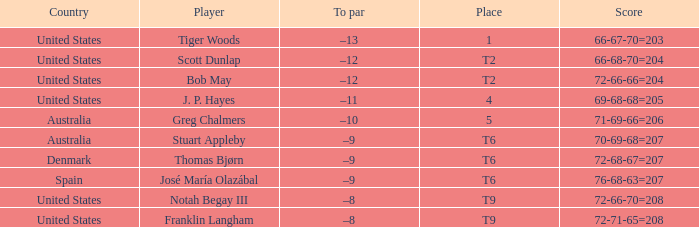What is the place of the player with a 66-68-70=204 score? T2. 